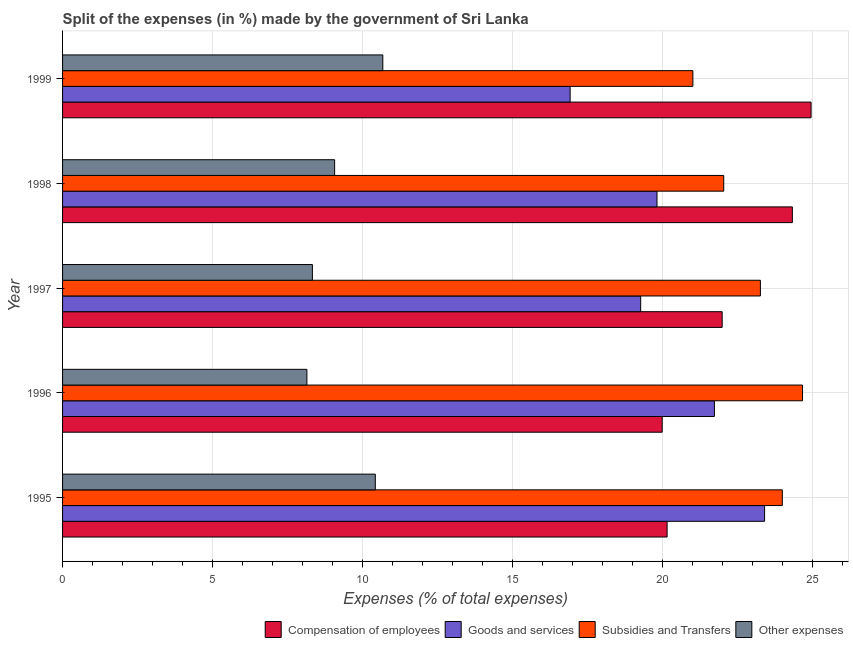How many different coloured bars are there?
Provide a succinct answer. 4. In how many cases, is the number of bars for a given year not equal to the number of legend labels?
Your response must be concise. 0. What is the percentage of amount spent on goods and services in 1998?
Ensure brevity in your answer.  19.81. Across all years, what is the maximum percentage of amount spent on goods and services?
Provide a succinct answer. 23.39. Across all years, what is the minimum percentage of amount spent on other expenses?
Your answer should be very brief. 8.14. In which year was the percentage of amount spent on compensation of employees minimum?
Your answer should be very brief. 1996. What is the total percentage of amount spent on subsidies in the graph?
Keep it short and to the point. 114.93. What is the difference between the percentage of amount spent on goods and services in 1996 and that in 1998?
Provide a succinct answer. 1.91. What is the difference between the percentage of amount spent on goods and services in 1995 and the percentage of amount spent on compensation of employees in 1996?
Offer a very short reply. 3.41. What is the average percentage of amount spent on goods and services per year?
Provide a succinct answer. 20.22. In the year 1999, what is the difference between the percentage of amount spent on other expenses and percentage of amount spent on subsidies?
Offer a terse response. -10.33. What is the ratio of the percentage of amount spent on other expenses in 1996 to that in 1997?
Your answer should be compact. 0.98. Is the percentage of amount spent on other expenses in 1996 less than that in 1999?
Keep it short and to the point. Yes. Is the difference between the percentage of amount spent on subsidies in 1995 and 1996 greater than the difference between the percentage of amount spent on compensation of employees in 1995 and 1996?
Provide a short and direct response. No. What is the difference between the highest and the second highest percentage of amount spent on compensation of employees?
Keep it short and to the point. 0.62. What is the difference between the highest and the lowest percentage of amount spent on subsidies?
Provide a succinct answer. 3.65. In how many years, is the percentage of amount spent on subsidies greater than the average percentage of amount spent on subsidies taken over all years?
Your response must be concise. 3. Is the sum of the percentage of amount spent on compensation of employees in 1998 and 1999 greater than the maximum percentage of amount spent on other expenses across all years?
Provide a succinct answer. Yes. Is it the case that in every year, the sum of the percentage of amount spent on other expenses and percentage of amount spent on subsidies is greater than the sum of percentage of amount spent on goods and services and percentage of amount spent on compensation of employees?
Offer a terse response. No. What does the 4th bar from the top in 1997 represents?
Your answer should be compact. Compensation of employees. What does the 1st bar from the bottom in 1998 represents?
Your answer should be compact. Compensation of employees. Are the values on the major ticks of X-axis written in scientific E-notation?
Provide a short and direct response. No. Does the graph contain any zero values?
Provide a succinct answer. No. How are the legend labels stacked?
Your answer should be very brief. Horizontal. What is the title of the graph?
Keep it short and to the point. Split of the expenses (in %) made by the government of Sri Lanka. What is the label or title of the X-axis?
Ensure brevity in your answer.  Expenses (% of total expenses). What is the label or title of the Y-axis?
Provide a succinct answer. Year. What is the Expenses (% of total expenses) in Compensation of employees in 1995?
Ensure brevity in your answer.  20.14. What is the Expenses (% of total expenses) of Goods and services in 1995?
Ensure brevity in your answer.  23.39. What is the Expenses (% of total expenses) in Subsidies and Transfers in 1995?
Offer a terse response. 23.98. What is the Expenses (% of total expenses) of Other expenses in 1995?
Offer a terse response. 10.42. What is the Expenses (% of total expenses) of Compensation of employees in 1996?
Your response must be concise. 19.98. What is the Expenses (% of total expenses) in Goods and services in 1996?
Give a very brief answer. 21.72. What is the Expenses (% of total expenses) of Subsidies and Transfers in 1996?
Offer a terse response. 24.66. What is the Expenses (% of total expenses) in Other expenses in 1996?
Offer a terse response. 8.14. What is the Expenses (% of total expenses) of Compensation of employees in 1997?
Give a very brief answer. 21.98. What is the Expenses (% of total expenses) in Goods and services in 1997?
Your answer should be compact. 19.26. What is the Expenses (% of total expenses) in Subsidies and Transfers in 1997?
Offer a terse response. 23.25. What is the Expenses (% of total expenses) in Other expenses in 1997?
Make the answer very short. 8.32. What is the Expenses (% of total expenses) in Compensation of employees in 1998?
Make the answer very short. 24.32. What is the Expenses (% of total expenses) of Goods and services in 1998?
Your answer should be compact. 19.81. What is the Expenses (% of total expenses) in Subsidies and Transfers in 1998?
Offer a very short reply. 22.03. What is the Expenses (% of total expenses) in Other expenses in 1998?
Offer a terse response. 9.07. What is the Expenses (% of total expenses) of Compensation of employees in 1999?
Give a very brief answer. 24.94. What is the Expenses (% of total expenses) in Goods and services in 1999?
Your answer should be compact. 16.91. What is the Expenses (% of total expenses) in Subsidies and Transfers in 1999?
Offer a terse response. 21. What is the Expenses (% of total expenses) of Other expenses in 1999?
Your answer should be very brief. 10.67. Across all years, what is the maximum Expenses (% of total expenses) of Compensation of employees?
Make the answer very short. 24.94. Across all years, what is the maximum Expenses (% of total expenses) of Goods and services?
Give a very brief answer. 23.39. Across all years, what is the maximum Expenses (% of total expenses) in Subsidies and Transfers?
Keep it short and to the point. 24.66. Across all years, what is the maximum Expenses (% of total expenses) in Other expenses?
Keep it short and to the point. 10.67. Across all years, what is the minimum Expenses (% of total expenses) in Compensation of employees?
Offer a terse response. 19.98. Across all years, what is the minimum Expenses (% of total expenses) of Goods and services?
Keep it short and to the point. 16.91. Across all years, what is the minimum Expenses (% of total expenses) of Subsidies and Transfers?
Offer a very short reply. 21. Across all years, what is the minimum Expenses (% of total expenses) in Other expenses?
Offer a terse response. 8.14. What is the total Expenses (% of total expenses) in Compensation of employees in the graph?
Provide a short and direct response. 111.36. What is the total Expenses (% of total expenses) in Goods and services in the graph?
Make the answer very short. 101.1. What is the total Expenses (% of total expenses) of Subsidies and Transfers in the graph?
Provide a succinct answer. 114.93. What is the total Expenses (% of total expenses) in Other expenses in the graph?
Provide a succinct answer. 46.62. What is the difference between the Expenses (% of total expenses) of Compensation of employees in 1995 and that in 1996?
Your response must be concise. 0.16. What is the difference between the Expenses (% of total expenses) in Goods and services in 1995 and that in 1996?
Make the answer very short. 1.67. What is the difference between the Expenses (% of total expenses) of Subsidies and Transfers in 1995 and that in 1996?
Ensure brevity in your answer.  -0.67. What is the difference between the Expenses (% of total expenses) in Other expenses in 1995 and that in 1996?
Provide a short and direct response. 2.28. What is the difference between the Expenses (% of total expenses) of Compensation of employees in 1995 and that in 1997?
Your answer should be very brief. -1.83. What is the difference between the Expenses (% of total expenses) of Goods and services in 1995 and that in 1997?
Give a very brief answer. 4.13. What is the difference between the Expenses (% of total expenses) in Subsidies and Transfers in 1995 and that in 1997?
Give a very brief answer. 0.73. What is the difference between the Expenses (% of total expenses) in Other expenses in 1995 and that in 1997?
Provide a succinct answer. 2.1. What is the difference between the Expenses (% of total expenses) of Compensation of employees in 1995 and that in 1998?
Ensure brevity in your answer.  -4.17. What is the difference between the Expenses (% of total expenses) in Goods and services in 1995 and that in 1998?
Your answer should be compact. 3.59. What is the difference between the Expenses (% of total expenses) of Subsidies and Transfers in 1995 and that in 1998?
Offer a very short reply. 1.95. What is the difference between the Expenses (% of total expenses) in Other expenses in 1995 and that in 1998?
Your answer should be very brief. 1.36. What is the difference between the Expenses (% of total expenses) in Compensation of employees in 1995 and that in 1999?
Offer a terse response. -4.8. What is the difference between the Expenses (% of total expenses) in Goods and services in 1995 and that in 1999?
Make the answer very short. 6.48. What is the difference between the Expenses (% of total expenses) of Subsidies and Transfers in 1995 and that in 1999?
Provide a succinct answer. 2.98. What is the difference between the Expenses (% of total expenses) in Other expenses in 1995 and that in 1999?
Keep it short and to the point. -0.25. What is the difference between the Expenses (% of total expenses) of Compensation of employees in 1996 and that in 1997?
Your answer should be compact. -2. What is the difference between the Expenses (% of total expenses) of Goods and services in 1996 and that in 1997?
Your answer should be compact. 2.46. What is the difference between the Expenses (% of total expenses) in Subsidies and Transfers in 1996 and that in 1997?
Your answer should be compact. 1.4. What is the difference between the Expenses (% of total expenses) of Other expenses in 1996 and that in 1997?
Provide a succinct answer. -0.18. What is the difference between the Expenses (% of total expenses) in Compensation of employees in 1996 and that in 1998?
Give a very brief answer. -4.34. What is the difference between the Expenses (% of total expenses) of Goods and services in 1996 and that in 1998?
Your response must be concise. 1.91. What is the difference between the Expenses (% of total expenses) in Subsidies and Transfers in 1996 and that in 1998?
Offer a very short reply. 2.63. What is the difference between the Expenses (% of total expenses) in Other expenses in 1996 and that in 1998?
Your response must be concise. -0.92. What is the difference between the Expenses (% of total expenses) in Compensation of employees in 1996 and that in 1999?
Give a very brief answer. -4.96. What is the difference between the Expenses (% of total expenses) of Goods and services in 1996 and that in 1999?
Ensure brevity in your answer.  4.81. What is the difference between the Expenses (% of total expenses) in Subsidies and Transfers in 1996 and that in 1999?
Offer a terse response. 3.65. What is the difference between the Expenses (% of total expenses) in Other expenses in 1996 and that in 1999?
Your answer should be very brief. -2.53. What is the difference between the Expenses (% of total expenses) of Compensation of employees in 1997 and that in 1998?
Offer a very short reply. -2.34. What is the difference between the Expenses (% of total expenses) of Goods and services in 1997 and that in 1998?
Provide a short and direct response. -0.54. What is the difference between the Expenses (% of total expenses) in Subsidies and Transfers in 1997 and that in 1998?
Your answer should be compact. 1.22. What is the difference between the Expenses (% of total expenses) in Other expenses in 1997 and that in 1998?
Offer a terse response. -0.74. What is the difference between the Expenses (% of total expenses) of Compensation of employees in 1997 and that in 1999?
Your answer should be very brief. -2.96. What is the difference between the Expenses (% of total expenses) of Goods and services in 1997 and that in 1999?
Ensure brevity in your answer.  2.35. What is the difference between the Expenses (% of total expenses) in Subsidies and Transfers in 1997 and that in 1999?
Offer a very short reply. 2.25. What is the difference between the Expenses (% of total expenses) of Other expenses in 1997 and that in 1999?
Keep it short and to the point. -2.35. What is the difference between the Expenses (% of total expenses) of Compensation of employees in 1998 and that in 1999?
Your answer should be very brief. -0.62. What is the difference between the Expenses (% of total expenses) in Goods and services in 1998 and that in 1999?
Give a very brief answer. 2.89. What is the difference between the Expenses (% of total expenses) in Subsidies and Transfers in 1998 and that in 1999?
Your answer should be very brief. 1.03. What is the difference between the Expenses (% of total expenses) of Other expenses in 1998 and that in 1999?
Make the answer very short. -1.61. What is the difference between the Expenses (% of total expenses) in Compensation of employees in 1995 and the Expenses (% of total expenses) in Goods and services in 1996?
Provide a succinct answer. -1.58. What is the difference between the Expenses (% of total expenses) of Compensation of employees in 1995 and the Expenses (% of total expenses) of Subsidies and Transfers in 1996?
Your response must be concise. -4.51. What is the difference between the Expenses (% of total expenses) in Compensation of employees in 1995 and the Expenses (% of total expenses) in Other expenses in 1996?
Your answer should be very brief. 12. What is the difference between the Expenses (% of total expenses) in Goods and services in 1995 and the Expenses (% of total expenses) in Subsidies and Transfers in 1996?
Your answer should be compact. -1.26. What is the difference between the Expenses (% of total expenses) of Goods and services in 1995 and the Expenses (% of total expenses) of Other expenses in 1996?
Make the answer very short. 15.25. What is the difference between the Expenses (% of total expenses) in Subsidies and Transfers in 1995 and the Expenses (% of total expenses) in Other expenses in 1996?
Your answer should be compact. 15.84. What is the difference between the Expenses (% of total expenses) of Compensation of employees in 1995 and the Expenses (% of total expenses) of Goods and services in 1997?
Give a very brief answer. 0.88. What is the difference between the Expenses (% of total expenses) of Compensation of employees in 1995 and the Expenses (% of total expenses) of Subsidies and Transfers in 1997?
Offer a very short reply. -3.11. What is the difference between the Expenses (% of total expenses) of Compensation of employees in 1995 and the Expenses (% of total expenses) of Other expenses in 1997?
Keep it short and to the point. 11.82. What is the difference between the Expenses (% of total expenses) in Goods and services in 1995 and the Expenses (% of total expenses) in Subsidies and Transfers in 1997?
Ensure brevity in your answer.  0.14. What is the difference between the Expenses (% of total expenses) in Goods and services in 1995 and the Expenses (% of total expenses) in Other expenses in 1997?
Your answer should be very brief. 15.07. What is the difference between the Expenses (% of total expenses) of Subsidies and Transfers in 1995 and the Expenses (% of total expenses) of Other expenses in 1997?
Offer a very short reply. 15.66. What is the difference between the Expenses (% of total expenses) in Compensation of employees in 1995 and the Expenses (% of total expenses) in Goods and services in 1998?
Your answer should be compact. 0.34. What is the difference between the Expenses (% of total expenses) of Compensation of employees in 1995 and the Expenses (% of total expenses) of Subsidies and Transfers in 1998?
Offer a terse response. -1.89. What is the difference between the Expenses (% of total expenses) of Compensation of employees in 1995 and the Expenses (% of total expenses) of Other expenses in 1998?
Give a very brief answer. 11.08. What is the difference between the Expenses (% of total expenses) in Goods and services in 1995 and the Expenses (% of total expenses) in Subsidies and Transfers in 1998?
Make the answer very short. 1.36. What is the difference between the Expenses (% of total expenses) in Goods and services in 1995 and the Expenses (% of total expenses) in Other expenses in 1998?
Give a very brief answer. 14.33. What is the difference between the Expenses (% of total expenses) of Subsidies and Transfers in 1995 and the Expenses (% of total expenses) of Other expenses in 1998?
Your answer should be compact. 14.92. What is the difference between the Expenses (% of total expenses) in Compensation of employees in 1995 and the Expenses (% of total expenses) in Goods and services in 1999?
Give a very brief answer. 3.23. What is the difference between the Expenses (% of total expenses) in Compensation of employees in 1995 and the Expenses (% of total expenses) in Subsidies and Transfers in 1999?
Provide a succinct answer. -0.86. What is the difference between the Expenses (% of total expenses) in Compensation of employees in 1995 and the Expenses (% of total expenses) in Other expenses in 1999?
Provide a succinct answer. 9.47. What is the difference between the Expenses (% of total expenses) of Goods and services in 1995 and the Expenses (% of total expenses) of Subsidies and Transfers in 1999?
Keep it short and to the point. 2.39. What is the difference between the Expenses (% of total expenses) of Goods and services in 1995 and the Expenses (% of total expenses) of Other expenses in 1999?
Your response must be concise. 12.72. What is the difference between the Expenses (% of total expenses) in Subsidies and Transfers in 1995 and the Expenses (% of total expenses) in Other expenses in 1999?
Make the answer very short. 13.31. What is the difference between the Expenses (% of total expenses) of Compensation of employees in 1996 and the Expenses (% of total expenses) of Goods and services in 1997?
Your answer should be compact. 0.72. What is the difference between the Expenses (% of total expenses) in Compensation of employees in 1996 and the Expenses (% of total expenses) in Subsidies and Transfers in 1997?
Your response must be concise. -3.27. What is the difference between the Expenses (% of total expenses) in Compensation of employees in 1996 and the Expenses (% of total expenses) in Other expenses in 1997?
Make the answer very short. 11.66. What is the difference between the Expenses (% of total expenses) in Goods and services in 1996 and the Expenses (% of total expenses) in Subsidies and Transfers in 1997?
Your response must be concise. -1.53. What is the difference between the Expenses (% of total expenses) of Goods and services in 1996 and the Expenses (% of total expenses) of Other expenses in 1997?
Make the answer very short. 13.4. What is the difference between the Expenses (% of total expenses) in Subsidies and Transfers in 1996 and the Expenses (% of total expenses) in Other expenses in 1997?
Give a very brief answer. 16.33. What is the difference between the Expenses (% of total expenses) in Compensation of employees in 1996 and the Expenses (% of total expenses) in Goods and services in 1998?
Your answer should be very brief. 0.17. What is the difference between the Expenses (% of total expenses) in Compensation of employees in 1996 and the Expenses (% of total expenses) in Subsidies and Transfers in 1998?
Give a very brief answer. -2.05. What is the difference between the Expenses (% of total expenses) in Compensation of employees in 1996 and the Expenses (% of total expenses) in Other expenses in 1998?
Offer a terse response. 10.91. What is the difference between the Expenses (% of total expenses) of Goods and services in 1996 and the Expenses (% of total expenses) of Subsidies and Transfers in 1998?
Make the answer very short. -0.31. What is the difference between the Expenses (% of total expenses) in Goods and services in 1996 and the Expenses (% of total expenses) in Other expenses in 1998?
Your answer should be very brief. 12.66. What is the difference between the Expenses (% of total expenses) of Subsidies and Transfers in 1996 and the Expenses (% of total expenses) of Other expenses in 1998?
Give a very brief answer. 15.59. What is the difference between the Expenses (% of total expenses) in Compensation of employees in 1996 and the Expenses (% of total expenses) in Goods and services in 1999?
Your answer should be compact. 3.07. What is the difference between the Expenses (% of total expenses) of Compensation of employees in 1996 and the Expenses (% of total expenses) of Subsidies and Transfers in 1999?
Offer a very short reply. -1.02. What is the difference between the Expenses (% of total expenses) in Compensation of employees in 1996 and the Expenses (% of total expenses) in Other expenses in 1999?
Offer a terse response. 9.31. What is the difference between the Expenses (% of total expenses) of Goods and services in 1996 and the Expenses (% of total expenses) of Subsidies and Transfers in 1999?
Make the answer very short. 0.72. What is the difference between the Expenses (% of total expenses) of Goods and services in 1996 and the Expenses (% of total expenses) of Other expenses in 1999?
Keep it short and to the point. 11.05. What is the difference between the Expenses (% of total expenses) of Subsidies and Transfers in 1996 and the Expenses (% of total expenses) of Other expenses in 1999?
Make the answer very short. 13.99. What is the difference between the Expenses (% of total expenses) in Compensation of employees in 1997 and the Expenses (% of total expenses) in Goods and services in 1998?
Offer a terse response. 2.17. What is the difference between the Expenses (% of total expenses) in Compensation of employees in 1997 and the Expenses (% of total expenses) in Subsidies and Transfers in 1998?
Keep it short and to the point. -0.05. What is the difference between the Expenses (% of total expenses) in Compensation of employees in 1997 and the Expenses (% of total expenses) in Other expenses in 1998?
Offer a terse response. 12.91. What is the difference between the Expenses (% of total expenses) in Goods and services in 1997 and the Expenses (% of total expenses) in Subsidies and Transfers in 1998?
Offer a terse response. -2.77. What is the difference between the Expenses (% of total expenses) of Goods and services in 1997 and the Expenses (% of total expenses) of Other expenses in 1998?
Your answer should be very brief. 10.2. What is the difference between the Expenses (% of total expenses) in Subsidies and Transfers in 1997 and the Expenses (% of total expenses) in Other expenses in 1998?
Keep it short and to the point. 14.19. What is the difference between the Expenses (% of total expenses) in Compensation of employees in 1997 and the Expenses (% of total expenses) in Goods and services in 1999?
Give a very brief answer. 5.07. What is the difference between the Expenses (% of total expenses) in Compensation of employees in 1997 and the Expenses (% of total expenses) in Subsidies and Transfers in 1999?
Provide a succinct answer. 0.98. What is the difference between the Expenses (% of total expenses) of Compensation of employees in 1997 and the Expenses (% of total expenses) of Other expenses in 1999?
Ensure brevity in your answer.  11.31. What is the difference between the Expenses (% of total expenses) of Goods and services in 1997 and the Expenses (% of total expenses) of Subsidies and Transfers in 1999?
Ensure brevity in your answer.  -1.74. What is the difference between the Expenses (% of total expenses) of Goods and services in 1997 and the Expenses (% of total expenses) of Other expenses in 1999?
Keep it short and to the point. 8.59. What is the difference between the Expenses (% of total expenses) of Subsidies and Transfers in 1997 and the Expenses (% of total expenses) of Other expenses in 1999?
Your answer should be very brief. 12.58. What is the difference between the Expenses (% of total expenses) of Compensation of employees in 1998 and the Expenses (% of total expenses) of Goods and services in 1999?
Provide a succinct answer. 7.41. What is the difference between the Expenses (% of total expenses) in Compensation of employees in 1998 and the Expenses (% of total expenses) in Subsidies and Transfers in 1999?
Give a very brief answer. 3.32. What is the difference between the Expenses (% of total expenses) in Compensation of employees in 1998 and the Expenses (% of total expenses) in Other expenses in 1999?
Offer a terse response. 13.65. What is the difference between the Expenses (% of total expenses) in Goods and services in 1998 and the Expenses (% of total expenses) in Subsidies and Transfers in 1999?
Offer a very short reply. -1.2. What is the difference between the Expenses (% of total expenses) in Goods and services in 1998 and the Expenses (% of total expenses) in Other expenses in 1999?
Provide a succinct answer. 9.14. What is the difference between the Expenses (% of total expenses) in Subsidies and Transfers in 1998 and the Expenses (% of total expenses) in Other expenses in 1999?
Offer a terse response. 11.36. What is the average Expenses (% of total expenses) in Compensation of employees per year?
Provide a short and direct response. 22.27. What is the average Expenses (% of total expenses) in Goods and services per year?
Your answer should be very brief. 20.22. What is the average Expenses (% of total expenses) in Subsidies and Transfers per year?
Your answer should be very brief. 22.99. What is the average Expenses (% of total expenses) of Other expenses per year?
Your response must be concise. 9.32. In the year 1995, what is the difference between the Expenses (% of total expenses) of Compensation of employees and Expenses (% of total expenses) of Goods and services?
Your answer should be compact. -3.25. In the year 1995, what is the difference between the Expenses (% of total expenses) of Compensation of employees and Expenses (% of total expenses) of Subsidies and Transfers?
Your answer should be compact. -3.84. In the year 1995, what is the difference between the Expenses (% of total expenses) in Compensation of employees and Expenses (% of total expenses) in Other expenses?
Provide a succinct answer. 9.72. In the year 1995, what is the difference between the Expenses (% of total expenses) in Goods and services and Expenses (% of total expenses) in Subsidies and Transfers?
Make the answer very short. -0.59. In the year 1995, what is the difference between the Expenses (% of total expenses) in Goods and services and Expenses (% of total expenses) in Other expenses?
Keep it short and to the point. 12.97. In the year 1995, what is the difference between the Expenses (% of total expenses) in Subsidies and Transfers and Expenses (% of total expenses) in Other expenses?
Keep it short and to the point. 13.56. In the year 1996, what is the difference between the Expenses (% of total expenses) in Compensation of employees and Expenses (% of total expenses) in Goods and services?
Your response must be concise. -1.74. In the year 1996, what is the difference between the Expenses (% of total expenses) of Compensation of employees and Expenses (% of total expenses) of Subsidies and Transfers?
Your answer should be compact. -4.68. In the year 1996, what is the difference between the Expenses (% of total expenses) in Compensation of employees and Expenses (% of total expenses) in Other expenses?
Ensure brevity in your answer.  11.84. In the year 1996, what is the difference between the Expenses (% of total expenses) in Goods and services and Expenses (% of total expenses) in Subsidies and Transfers?
Make the answer very short. -2.94. In the year 1996, what is the difference between the Expenses (% of total expenses) in Goods and services and Expenses (% of total expenses) in Other expenses?
Ensure brevity in your answer.  13.58. In the year 1996, what is the difference between the Expenses (% of total expenses) of Subsidies and Transfers and Expenses (% of total expenses) of Other expenses?
Provide a short and direct response. 16.51. In the year 1997, what is the difference between the Expenses (% of total expenses) in Compensation of employees and Expenses (% of total expenses) in Goods and services?
Give a very brief answer. 2.72. In the year 1997, what is the difference between the Expenses (% of total expenses) of Compensation of employees and Expenses (% of total expenses) of Subsidies and Transfers?
Make the answer very short. -1.27. In the year 1997, what is the difference between the Expenses (% of total expenses) of Compensation of employees and Expenses (% of total expenses) of Other expenses?
Your answer should be compact. 13.65. In the year 1997, what is the difference between the Expenses (% of total expenses) in Goods and services and Expenses (% of total expenses) in Subsidies and Transfers?
Keep it short and to the point. -3.99. In the year 1997, what is the difference between the Expenses (% of total expenses) of Goods and services and Expenses (% of total expenses) of Other expenses?
Offer a very short reply. 10.94. In the year 1997, what is the difference between the Expenses (% of total expenses) of Subsidies and Transfers and Expenses (% of total expenses) of Other expenses?
Offer a very short reply. 14.93. In the year 1998, what is the difference between the Expenses (% of total expenses) in Compensation of employees and Expenses (% of total expenses) in Goods and services?
Your answer should be very brief. 4.51. In the year 1998, what is the difference between the Expenses (% of total expenses) in Compensation of employees and Expenses (% of total expenses) in Subsidies and Transfers?
Provide a succinct answer. 2.29. In the year 1998, what is the difference between the Expenses (% of total expenses) in Compensation of employees and Expenses (% of total expenses) in Other expenses?
Your answer should be very brief. 15.25. In the year 1998, what is the difference between the Expenses (% of total expenses) in Goods and services and Expenses (% of total expenses) in Subsidies and Transfers?
Provide a short and direct response. -2.22. In the year 1998, what is the difference between the Expenses (% of total expenses) in Goods and services and Expenses (% of total expenses) in Other expenses?
Your answer should be compact. 10.74. In the year 1998, what is the difference between the Expenses (% of total expenses) of Subsidies and Transfers and Expenses (% of total expenses) of Other expenses?
Provide a short and direct response. 12.97. In the year 1999, what is the difference between the Expenses (% of total expenses) of Compensation of employees and Expenses (% of total expenses) of Goods and services?
Give a very brief answer. 8.03. In the year 1999, what is the difference between the Expenses (% of total expenses) in Compensation of employees and Expenses (% of total expenses) in Subsidies and Transfers?
Provide a succinct answer. 3.94. In the year 1999, what is the difference between the Expenses (% of total expenses) in Compensation of employees and Expenses (% of total expenses) in Other expenses?
Offer a very short reply. 14.27. In the year 1999, what is the difference between the Expenses (% of total expenses) of Goods and services and Expenses (% of total expenses) of Subsidies and Transfers?
Provide a short and direct response. -4.09. In the year 1999, what is the difference between the Expenses (% of total expenses) in Goods and services and Expenses (% of total expenses) in Other expenses?
Your answer should be very brief. 6.24. In the year 1999, what is the difference between the Expenses (% of total expenses) of Subsidies and Transfers and Expenses (% of total expenses) of Other expenses?
Provide a succinct answer. 10.33. What is the ratio of the Expenses (% of total expenses) of Compensation of employees in 1995 to that in 1996?
Keep it short and to the point. 1.01. What is the ratio of the Expenses (% of total expenses) of Goods and services in 1995 to that in 1996?
Offer a terse response. 1.08. What is the ratio of the Expenses (% of total expenses) of Subsidies and Transfers in 1995 to that in 1996?
Offer a very short reply. 0.97. What is the ratio of the Expenses (% of total expenses) of Other expenses in 1995 to that in 1996?
Provide a succinct answer. 1.28. What is the ratio of the Expenses (% of total expenses) of Compensation of employees in 1995 to that in 1997?
Make the answer very short. 0.92. What is the ratio of the Expenses (% of total expenses) of Goods and services in 1995 to that in 1997?
Provide a short and direct response. 1.21. What is the ratio of the Expenses (% of total expenses) of Subsidies and Transfers in 1995 to that in 1997?
Offer a very short reply. 1.03. What is the ratio of the Expenses (% of total expenses) of Other expenses in 1995 to that in 1997?
Make the answer very short. 1.25. What is the ratio of the Expenses (% of total expenses) in Compensation of employees in 1995 to that in 1998?
Ensure brevity in your answer.  0.83. What is the ratio of the Expenses (% of total expenses) of Goods and services in 1995 to that in 1998?
Provide a succinct answer. 1.18. What is the ratio of the Expenses (% of total expenses) of Subsidies and Transfers in 1995 to that in 1998?
Keep it short and to the point. 1.09. What is the ratio of the Expenses (% of total expenses) of Other expenses in 1995 to that in 1998?
Provide a short and direct response. 1.15. What is the ratio of the Expenses (% of total expenses) in Compensation of employees in 1995 to that in 1999?
Your answer should be very brief. 0.81. What is the ratio of the Expenses (% of total expenses) in Goods and services in 1995 to that in 1999?
Your answer should be compact. 1.38. What is the ratio of the Expenses (% of total expenses) of Subsidies and Transfers in 1995 to that in 1999?
Make the answer very short. 1.14. What is the ratio of the Expenses (% of total expenses) of Other expenses in 1995 to that in 1999?
Keep it short and to the point. 0.98. What is the ratio of the Expenses (% of total expenses) of Compensation of employees in 1996 to that in 1997?
Your answer should be very brief. 0.91. What is the ratio of the Expenses (% of total expenses) in Goods and services in 1996 to that in 1997?
Offer a very short reply. 1.13. What is the ratio of the Expenses (% of total expenses) of Subsidies and Transfers in 1996 to that in 1997?
Keep it short and to the point. 1.06. What is the ratio of the Expenses (% of total expenses) in Other expenses in 1996 to that in 1997?
Ensure brevity in your answer.  0.98. What is the ratio of the Expenses (% of total expenses) of Compensation of employees in 1996 to that in 1998?
Your response must be concise. 0.82. What is the ratio of the Expenses (% of total expenses) of Goods and services in 1996 to that in 1998?
Your answer should be compact. 1.1. What is the ratio of the Expenses (% of total expenses) in Subsidies and Transfers in 1996 to that in 1998?
Offer a terse response. 1.12. What is the ratio of the Expenses (% of total expenses) of Other expenses in 1996 to that in 1998?
Ensure brevity in your answer.  0.9. What is the ratio of the Expenses (% of total expenses) of Compensation of employees in 1996 to that in 1999?
Make the answer very short. 0.8. What is the ratio of the Expenses (% of total expenses) in Goods and services in 1996 to that in 1999?
Your answer should be very brief. 1.28. What is the ratio of the Expenses (% of total expenses) in Subsidies and Transfers in 1996 to that in 1999?
Make the answer very short. 1.17. What is the ratio of the Expenses (% of total expenses) of Other expenses in 1996 to that in 1999?
Your response must be concise. 0.76. What is the ratio of the Expenses (% of total expenses) of Compensation of employees in 1997 to that in 1998?
Provide a short and direct response. 0.9. What is the ratio of the Expenses (% of total expenses) in Goods and services in 1997 to that in 1998?
Your answer should be very brief. 0.97. What is the ratio of the Expenses (% of total expenses) in Subsidies and Transfers in 1997 to that in 1998?
Provide a short and direct response. 1.06. What is the ratio of the Expenses (% of total expenses) of Other expenses in 1997 to that in 1998?
Provide a succinct answer. 0.92. What is the ratio of the Expenses (% of total expenses) of Compensation of employees in 1997 to that in 1999?
Your response must be concise. 0.88. What is the ratio of the Expenses (% of total expenses) in Goods and services in 1997 to that in 1999?
Your response must be concise. 1.14. What is the ratio of the Expenses (% of total expenses) in Subsidies and Transfers in 1997 to that in 1999?
Keep it short and to the point. 1.11. What is the ratio of the Expenses (% of total expenses) of Other expenses in 1997 to that in 1999?
Your answer should be very brief. 0.78. What is the ratio of the Expenses (% of total expenses) in Compensation of employees in 1998 to that in 1999?
Your answer should be very brief. 0.97. What is the ratio of the Expenses (% of total expenses) of Goods and services in 1998 to that in 1999?
Offer a very short reply. 1.17. What is the ratio of the Expenses (% of total expenses) in Subsidies and Transfers in 1998 to that in 1999?
Your answer should be very brief. 1.05. What is the ratio of the Expenses (% of total expenses) in Other expenses in 1998 to that in 1999?
Keep it short and to the point. 0.85. What is the difference between the highest and the second highest Expenses (% of total expenses) of Compensation of employees?
Provide a short and direct response. 0.62. What is the difference between the highest and the second highest Expenses (% of total expenses) of Goods and services?
Offer a very short reply. 1.67. What is the difference between the highest and the second highest Expenses (% of total expenses) in Subsidies and Transfers?
Provide a succinct answer. 0.67. What is the difference between the highest and the second highest Expenses (% of total expenses) of Other expenses?
Ensure brevity in your answer.  0.25. What is the difference between the highest and the lowest Expenses (% of total expenses) in Compensation of employees?
Make the answer very short. 4.96. What is the difference between the highest and the lowest Expenses (% of total expenses) of Goods and services?
Keep it short and to the point. 6.48. What is the difference between the highest and the lowest Expenses (% of total expenses) in Subsidies and Transfers?
Your answer should be compact. 3.65. What is the difference between the highest and the lowest Expenses (% of total expenses) in Other expenses?
Your answer should be very brief. 2.53. 